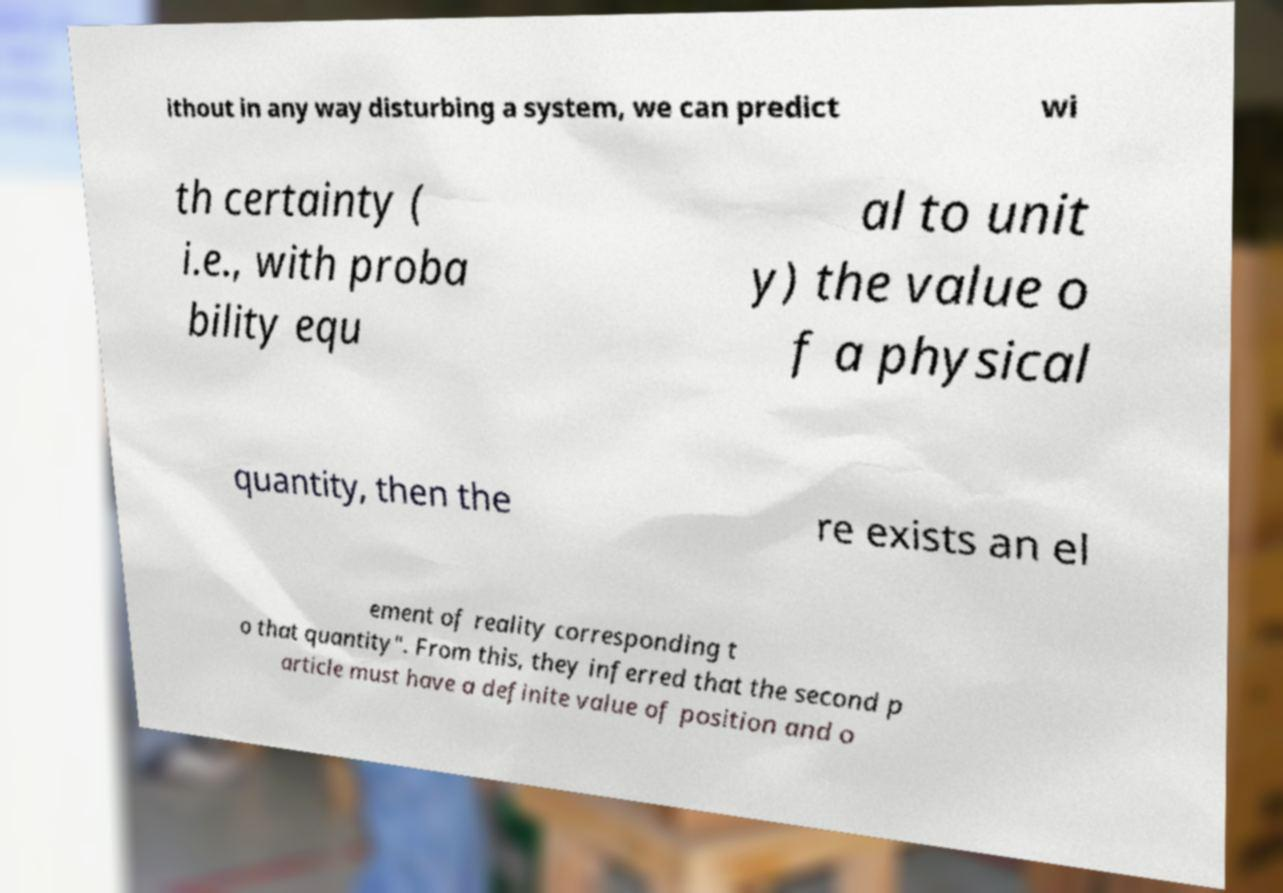Please identify and transcribe the text found in this image. ithout in any way disturbing a system, we can predict wi th certainty ( i.e., with proba bility equ al to unit y) the value o f a physical quantity, then the re exists an el ement of reality corresponding t o that quantity". From this, they inferred that the second p article must have a definite value of position and o 